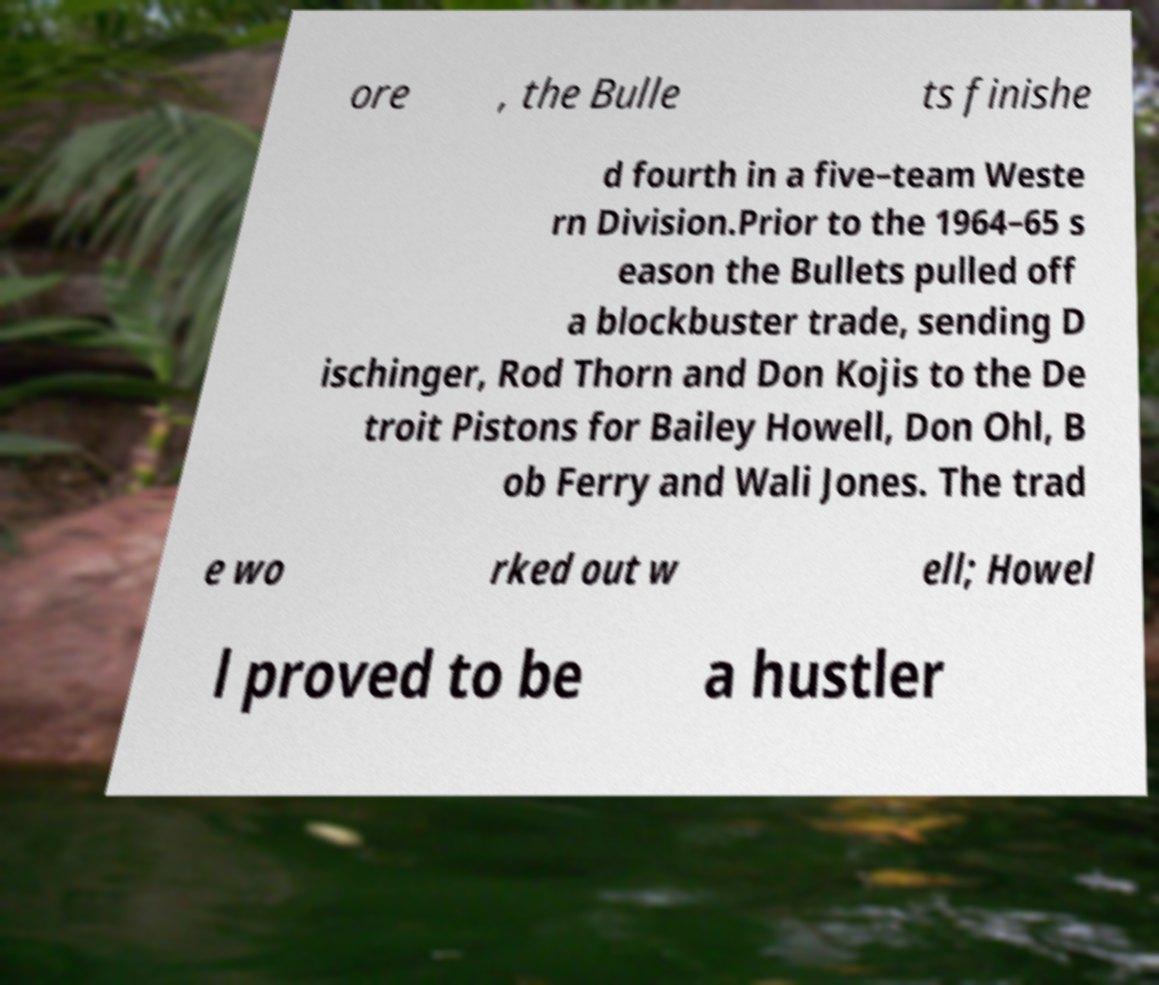Please identify and transcribe the text found in this image. ore , the Bulle ts finishe d fourth in a five–team Weste rn Division.Prior to the 1964–65 s eason the Bullets pulled off a blockbuster trade, sending D ischinger, Rod Thorn and Don Kojis to the De troit Pistons for Bailey Howell, Don Ohl, B ob Ferry and Wali Jones. The trad e wo rked out w ell; Howel l proved to be a hustler 